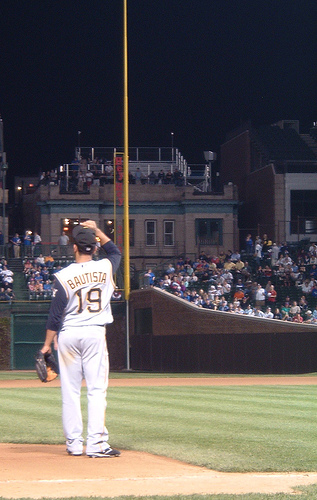What details in the image suggest it might be a significant moment in the game? The intense focus of 'BAUTISTA' as he stands by the third baseline, his gaze directed towards the pitcher or batter, suggests a critical moment. His readiness and positioning imply that a play of importance is about to unfold, heightened by the engaged audience in the background. 